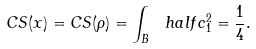Convert formula to latex. <formula><loc_0><loc_0><loc_500><loc_500>C S ( x ) = C S ( \rho ) = \int _ { B } \ h a l f c _ { 1 } ^ { 2 } = \frac { 1 } { 4 } .</formula> 